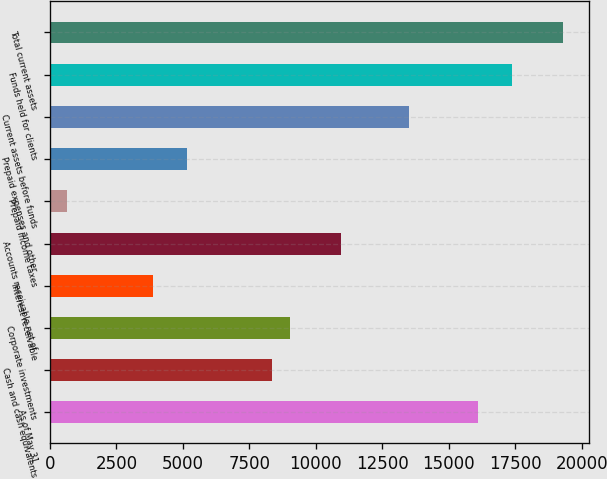Convert chart. <chart><loc_0><loc_0><loc_500><loc_500><bar_chart><fcel>As of May 31<fcel>Cash and cash equivalents<fcel>Corporate investments<fcel>Interest receivable<fcel>Accounts receivable net of<fcel>Prepaid income taxes<fcel>Prepaid expenses and other<fcel>Current assets before funds<fcel>Funds held for clients<fcel>Total current assets<nl><fcel>16096.6<fcel>8371.96<fcel>9015.68<fcel>3865.92<fcel>10946.8<fcel>647.32<fcel>5153.36<fcel>13521.7<fcel>17384<fcel>19315.2<nl></chart> 